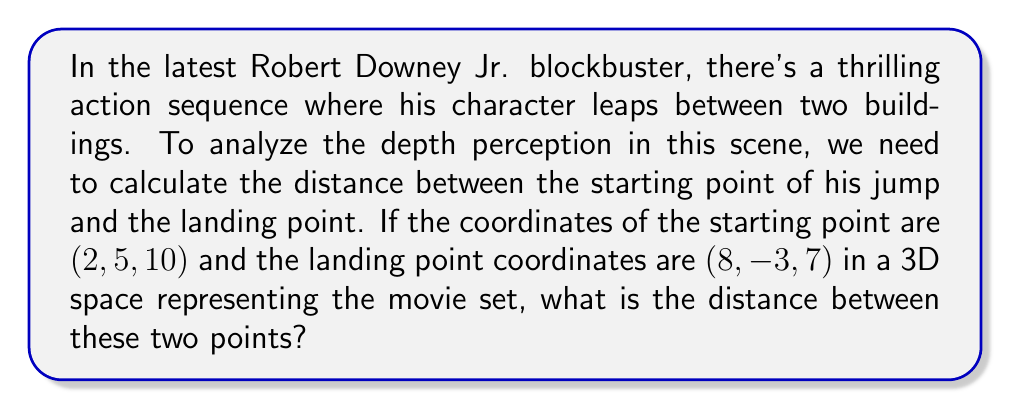Solve this math problem. To calculate the distance between two points in a 3D coordinate system, we use the distance formula derived from the Pythagorean theorem:

$$d = \sqrt{(x_2-x_1)^2 + (y_2-y_1)^2 + (z_2-z_1)^2}$$

Where $(x_1, y_1, z_1)$ is the starting point and $(x_2, y_2, z_2)$ is the ending point.

Let's plug in our values:
$(x_1, y_1, z_1) = (2, 5, 10)$
$(x_2, y_2, z_2) = (8, -3, 7)$

Now, let's calculate each part inside the square root:

1. $(x_2-x_1)^2 = (8-2)^2 = 6^2 = 36$
2. $(y_2-y_1)^2 = (-3-5)^2 = (-8)^2 = 64$
3. $(z_2-z_1)^2 = (7-10)^2 = (-3)^2 = 9$

Adding these up:

$$d = \sqrt{36 + 64 + 9} = \sqrt{109}$$

To simplify this, we can leave it as $\sqrt{109}$ or use a calculator to get an approximate decimal value.

Using a calculator: $\sqrt{109} \approx 10.44$ (rounded to two decimal places)

This means Robert Downey Jr.'s character jumped approximately 10.44 units (e.g., meters) between the buildings, giving us a sense of the depth and scale of the action in this thrilling scene.
Answer: The distance between the two points is $\sqrt{109}$ units, or approximately 10.44 units when rounded to two decimal places. 